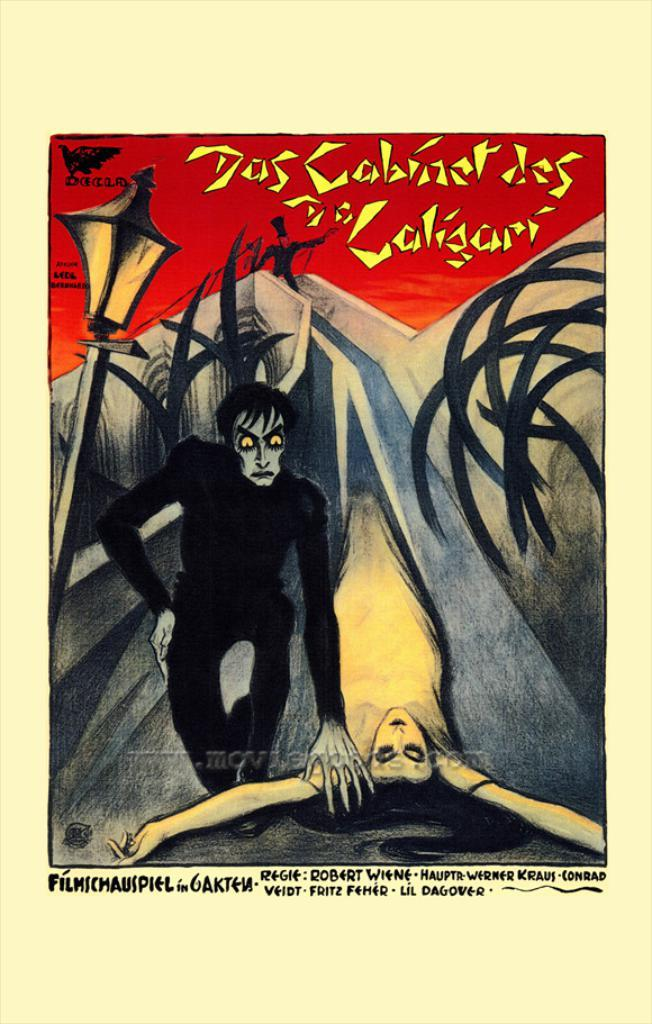What is featured on the poster in the image? There is a poster in the image that has words, a logo, an image of three persons, and a light with a pole. Can you describe the image of the three persons on the poster? The poster features an image of three persons. What is the purpose of the logo on the poster? The logo on the poster is likely used to identify a brand, organization, or event. What type of hat is the cub wearing in the image? There is no cub or hat present in the image; it features a poster with words, a logo, an image of three persons, and a light with a pole. 